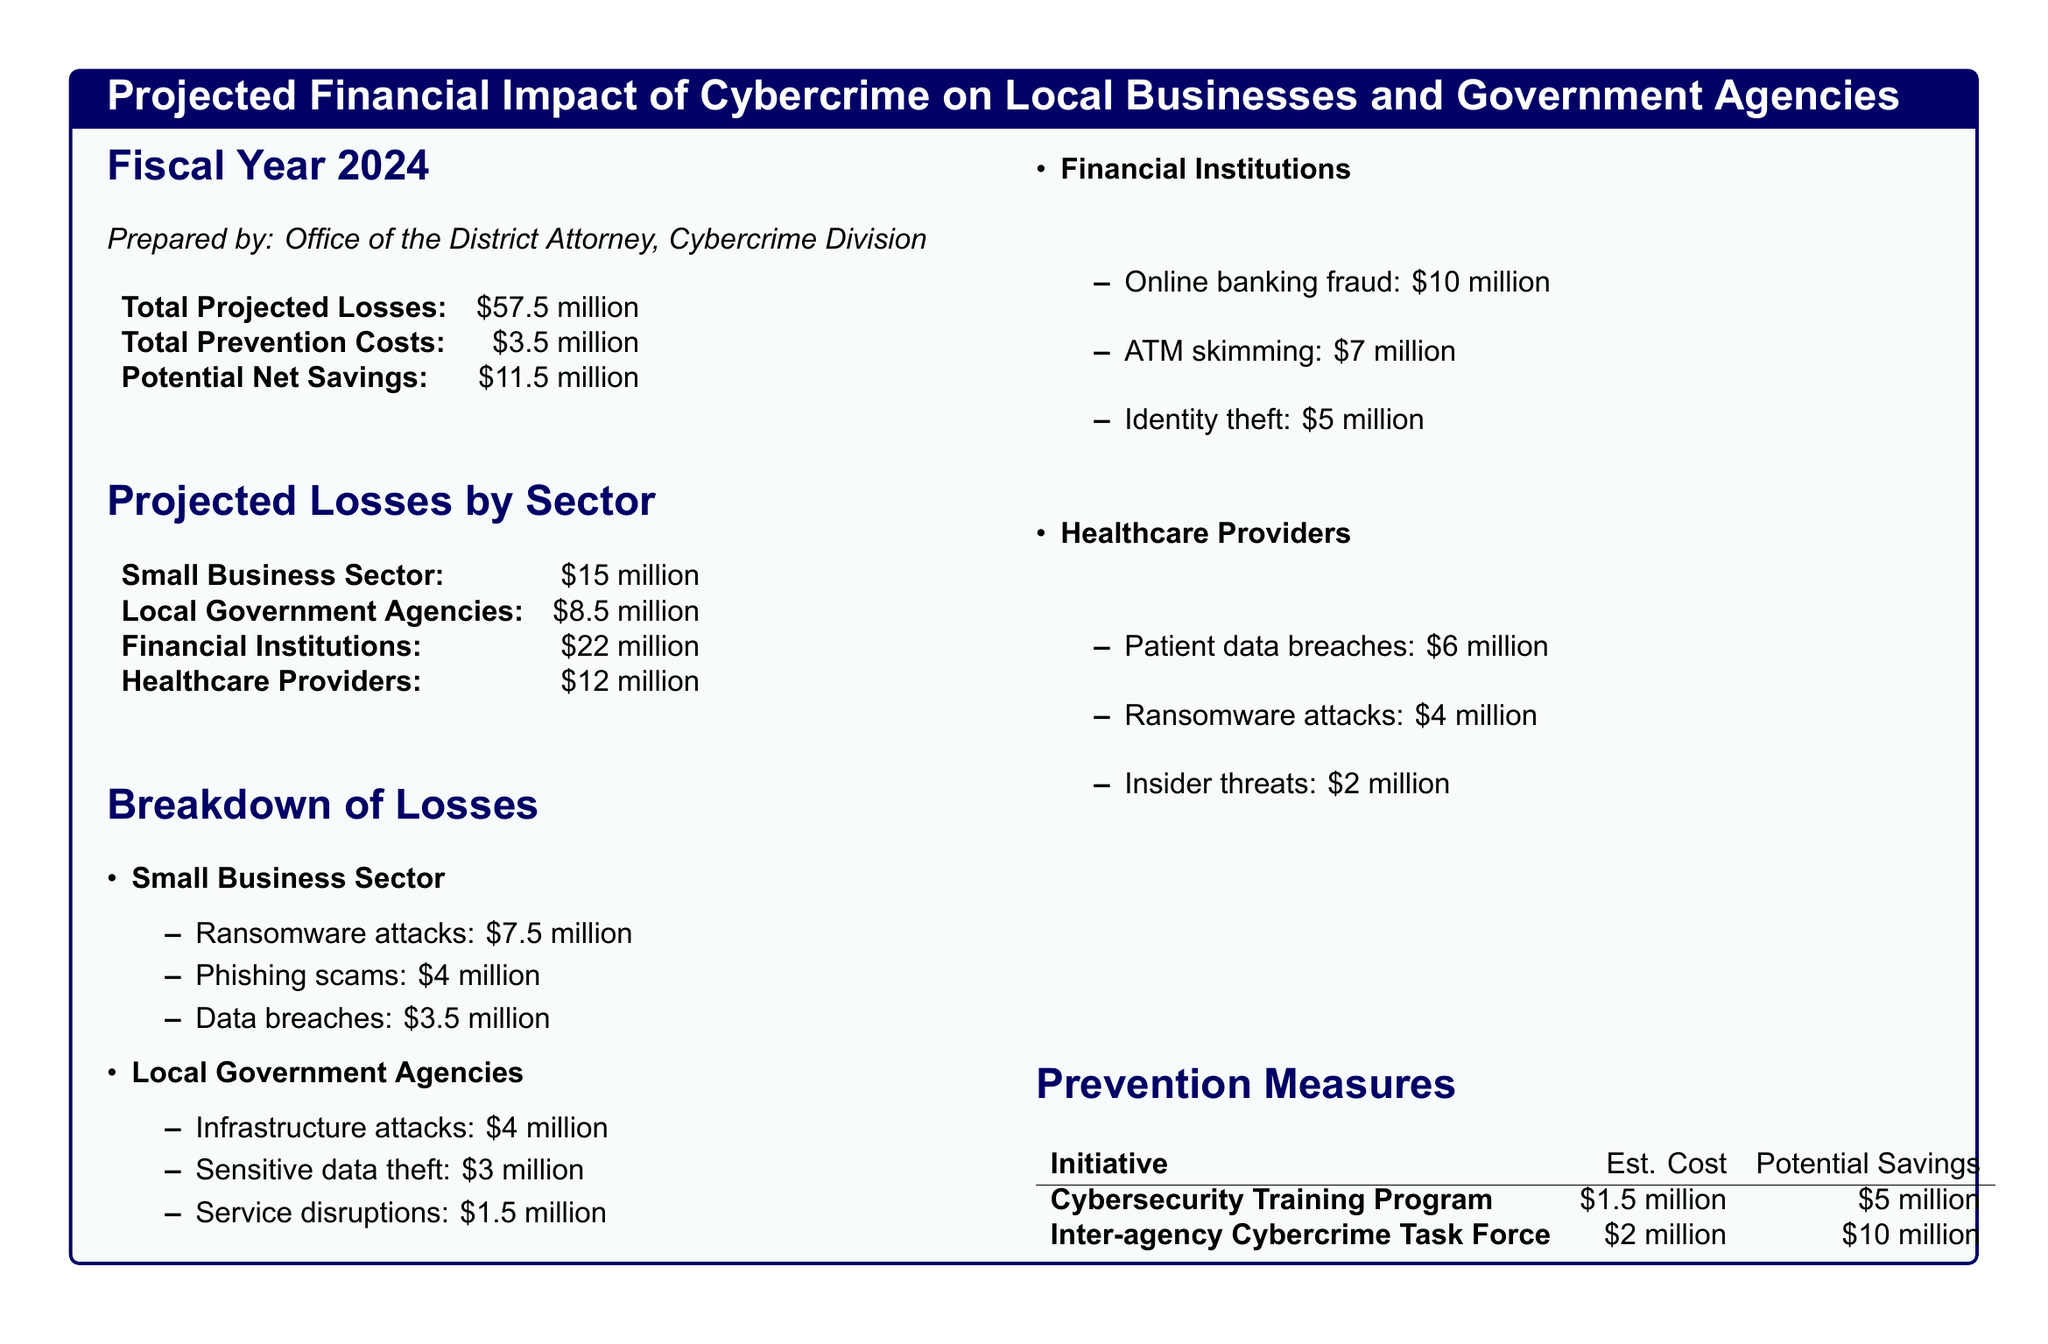What is the total projected loss? The total projected loss can be found in the financial summary of the document, which states it clearly.
Answer: $57.5 million What are the total prevention costs? The document specifies the total prevention costs directly under the financial summary section.
Answer: $3.5 million What potential net savings are projected? The potential net savings are mentioned in the summary, indicating the financial benefits after losses and costs.
Answer: $11.5 million Which sector has the highest projected losses? By reviewing the projected losses by sector, we can identify the sector with the highest figures.
Answer: Financial Institutions What is the estimated cost of the Cybersecurity Training Program? The cost for the Cybersecurity Training Program is listed in the prevention measures section of the document.
Answer: $1.5 million What is the total amount lost due to ransomware attacks in the small business sector? This figure is specified in the breakdown of losses specifically for the small business sector.
Answer: $7.5 million How much is projected to be lost by local government agencies due to sensitive data theft? The document includes a breakdown of losses by sectors where sensitive data theft is mentioned for local government agencies.
Answer: $3 million What is the potential savings from forming an inter-agency Cybercrime Task Force? The document states potential savings associated with the task force under prevention measures clearly.
Answer: $10 million What type of attack causes the highest financial loss in financial institutions? The breakdown listed under financial institutions highlights the attack type causing the highest loss.
Answer: Online banking fraud 